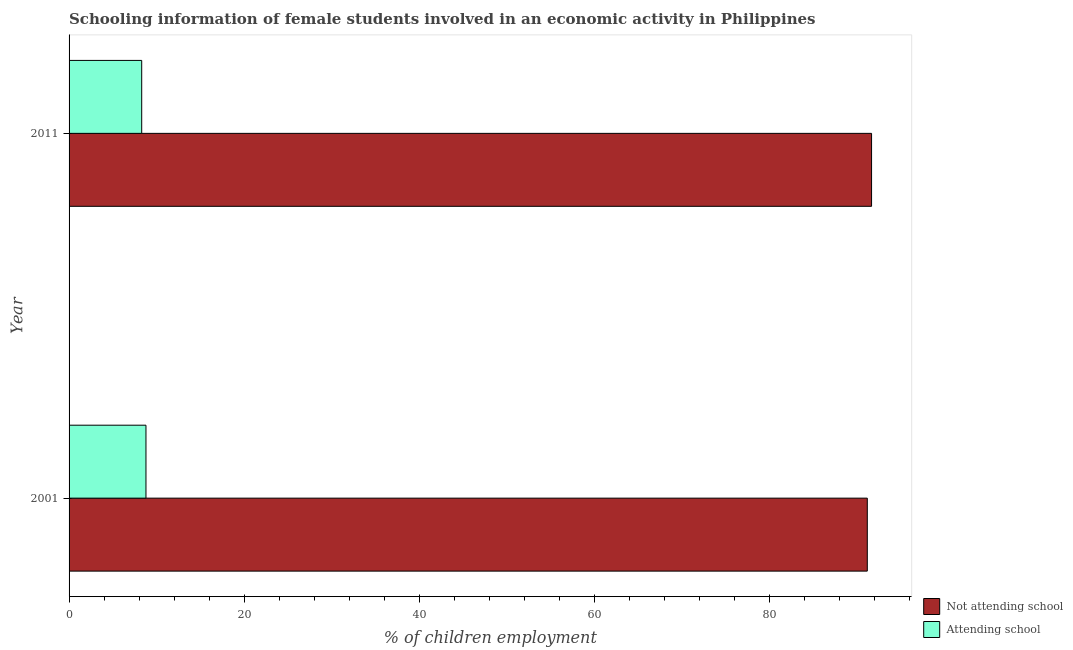How many groups of bars are there?
Ensure brevity in your answer.  2. Are the number of bars on each tick of the Y-axis equal?
Offer a terse response. Yes. How many bars are there on the 2nd tick from the bottom?
Keep it short and to the point. 2. What is the percentage of employed females who are attending school in 2001?
Offer a very short reply. 8.79. Across all years, what is the maximum percentage of employed females who are attending school?
Provide a succinct answer. 8.79. Across all years, what is the minimum percentage of employed females who are not attending school?
Offer a terse response. 91.21. In which year was the percentage of employed females who are attending school minimum?
Make the answer very short. 2011. What is the total percentage of employed females who are not attending school in the graph?
Keep it short and to the point. 182.91. What is the difference between the percentage of employed females who are attending school in 2001 and that in 2011?
Provide a short and direct response. 0.49. What is the difference between the percentage of employed females who are attending school in 2011 and the percentage of employed females who are not attending school in 2001?
Your answer should be very brief. -82.91. What is the average percentage of employed females who are not attending school per year?
Provide a succinct answer. 91.46. In the year 2011, what is the difference between the percentage of employed females who are attending school and percentage of employed females who are not attending school?
Your response must be concise. -83.4. In how many years, is the percentage of employed females who are attending school greater than 36 %?
Give a very brief answer. 0. What is the ratio of the percentage of employed females who are attending school in 2001 to that in 2011?
Your answer should be very brief. 1.06. What does the 1st bar from the top in 2011 represents?
Your response must be concise. Attending school. What does the 1st bar from the bottom in 2011 represents?
Give a very brief answer. Not attending school. How many bars are there?
Keep it short and to the point. 4. Are all the bars in the graph horizontal?
Give a very brief answer. Yes. How many years are there in the graph?
Offer a very short reply. 2. Are the values on the major ticks of X-axis written in scientific E-notation?
Your answer should be very brief. No. Does the graph contain any zero values?
Offer a terse response. No. Where does the legend appear in the graph?
Make the answer very short. Bottom right. How are the legend labels stacked?
Your answer should be very brief. Vertical. What is the title of the graph?
Your answer should be very brief. Schooling information of female students involved in an economic activity in Philippines. Does "Private consumption" appear as one of the legend labels in the graph?
Offer a very short reply. No. What is the label or title of the X-axis?
Make the answer very short. % of children employment. What is the % of children employment of Not attending school in 2001?
Ensure brevity in your answer.  91.21. What is the % of children employment in Attending school in 2001?
Make the answer very short. 8.79. What is the % of children employment in Not attending school in 2011?
Your answer should be compact. 91.7. Across all years, what is the maximum % of children employment of Not attending school?
Give a very brief answer. 91.7. Across all years, what is the maximum % of children employment in Attending school?
Your answer should be compact. 8.79. Across all years, what is the minimum % of children employment in Not attending school?
Offer a terse response. 91.21. Across all years, what is the minimum % of children employment of Attending school?
Make the answer very short. 8.3. What is the total % of children employment of Not attending school in the graph?
Provide a short and direct response. 182.91. What is the total % of children employment in Attending school in the graph?
Give a very brief answer. 17.09. What is the difference between the % of children employment in Not attending school in 2001 and that in 2011?
Your answer should be compact. -0.49. What is the difference between the % of children employment of Attending school in 2001 and that in 2011?
Keep it short and to the point. 0.49. What is the difference between the % of children employment of Not attending school in 2001 and the % of children employment of Attending school in 2011?
Offer a terse response. 82.91. What is the average % of children employment in Not attending school per year?
Your answer should be compact. 91.46. What is the average % of children employment in Attending school per year?
Ensure brevity in your answer.  8.54. In the year 2001, what is the difference between the % of children employment in Not attending school and % of children employment in Attending school?
Offer a terse response. 82.43. In the year 2011, what is the difference between the % of children employment in Not attending school and % of children employment in Attending school?
Your response must be concise. 83.4. What is the ratio of the % of children employment of Attending school in 2001 to that in 2011?
Your answer should be very brief. 1.06. What is the difference between the highest and the second highest % of children employment in Not attending school?
Your answer should be very brief. 0.49. What is the difference between the highest and the second highest % of children employment of Attending school?
Your answer should be compact. 0.49. What is the difference between the highest and the lowest % of children employment of Not attending school?
Your answer should be compact. 0.49. What is the difference between the highest and the lowest % of children employment in Attending school?
Offer a terse response. 0.49. 